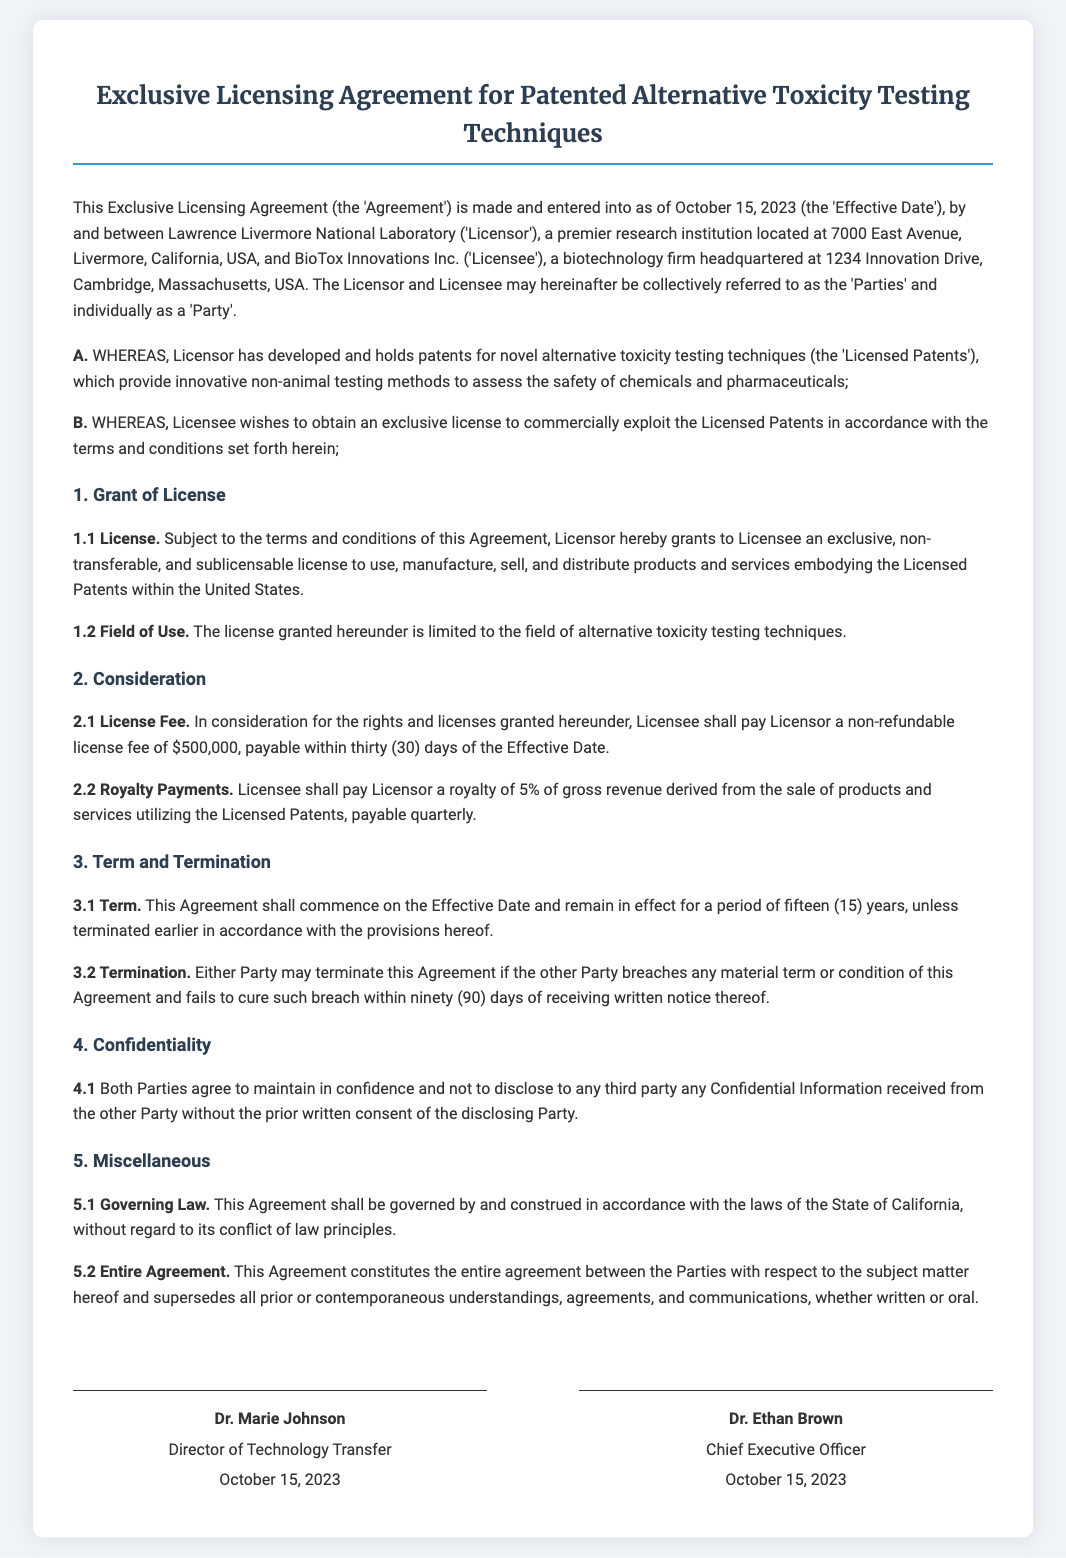What is the Effective Date of the Agreement? The Effective Date is specified at the beginning of the document as October 15, 2023.
Answer: October 15, 2023 Who are the Parties involved in the Agreement? The document mentions Lawrence Livermore National Laboratory as the Licensor and BioTox Innovations Inc. as the Licensee.
Answer: Lawrence Livermore National Laboratory and BioTox Innovations Inc What is the license fee amount? The license fee is clearly stated in the document as a non-refundable amount.
Answer: $500,000 How long is the term of the Agreement? The term of the Agreement is mentioned as fifteen years unless terminated earlier.
Answer: fifteen years What percentage is the royalty payment on gross revenue? The document states that the royalty payment is a percentage of gross revenue derived from the sale of products and services.
Answer: 5% What must a Party do to terminate the Agreement? To terminate the Agreement, one Party must breach a material term or condition and fail to cure the breach within a specified time.
Answer: fail to cure within ninety days What is the purpose of the Agreement? The Agreement's purpose is outlined in the preamble, detailing the exclusive license for alternative toxicity testing techniques.
Answer: exclusive license for alternative toxicity testing techniques What law governs this Agreement? The document specifies that the Agreement is governed by the laws of a specific state.
Answer: State of California 